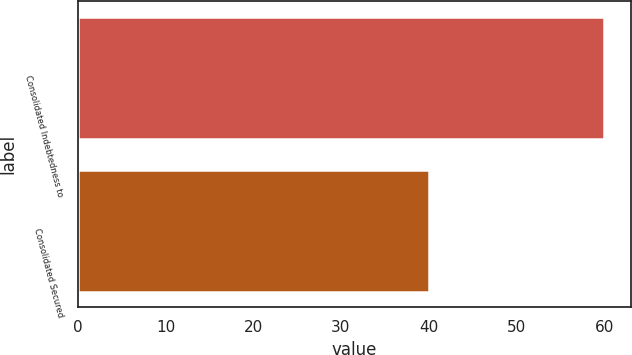<chart> <loc_0><loc_0><loc_500><loc_500><bar_chart><fcel>Consolidated Indebtedness to<fcel>Consolidated Secured<nl><fcel>60<fcel>40<nl></chart> 